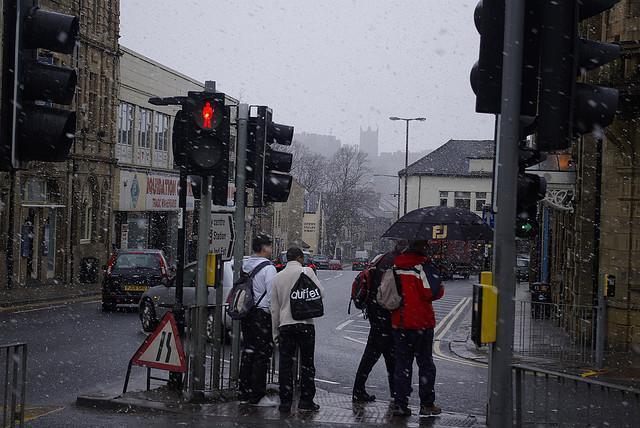How many people are using the road?
Give a very brief answer. 4. How many traffic lights can be seen?
Give a very brief answer. 5. How many backpacks are there?
Give a very brief answer. 1. How many cars are in the picture?
Give a very brief answer. 2. How many people are there?
Give a very brief answer. 4. 